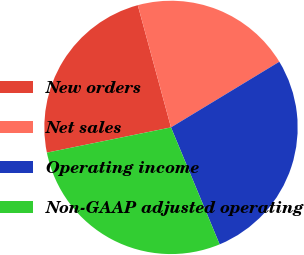<chart> <loc_0><loc_0><loc_500><loc_500><pie_chart><fcel>New orders<fcel>Net sales<fcel>Operating income<fcel>Non-GAAP adjusted operating<nl><fcel>23.97%<fcel>20.55%<fcel>27.4%<fcel>28.08%<nl></chart> 